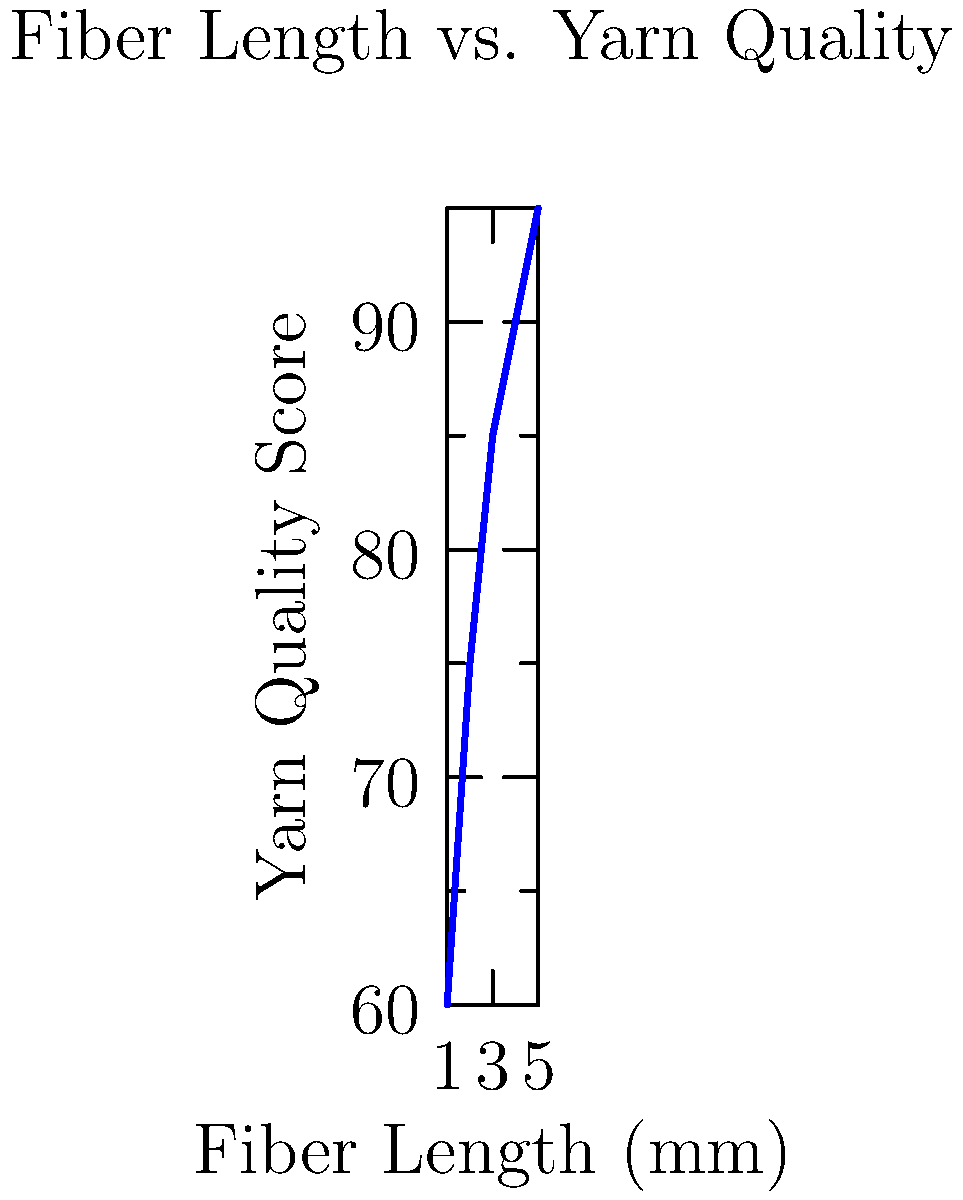Based on the graph showing the relationship between fiber length and yarn quality score, what would be the estimated quality score for recycled yarn made from fibers with an average length of 3.5 mm? To estimate the quality score for recycled yarn made from fibers with an average length of 3.5 mm, we need to follow these steps:

1. Observe the trend in the graph: As fiber length increases, yarn quality score increases.

2. Identify the data points:
   - (1 mm, 60)
   - (2 mm, 75)
   - (3 mm, 85)
   - (4 mm, 90)
   - (5 mm, 95)

3. Locate 3.5 mm on the x-axis: It falls between 3 mm and 4 mm.

4. Estimate the y-value (quality score) for 3.5 mm:
   - At 3 mm, the score is 85
   - At 4 mm, the score is 90
   - The difference is 5 points over 1 mm

5. Calculate the estimated score:
   - 3.5 mm is halfway between 3 mm and 4 mm
   - Half of the 5-point difference is 2.5 points
   - Estimated score = 85 + 2.5 = 87.5

Therefore, the estimated quality score for recycled yarn made from fibers with an average length of 3.5 mm is approximately 87.5.
Answer: 87.5 